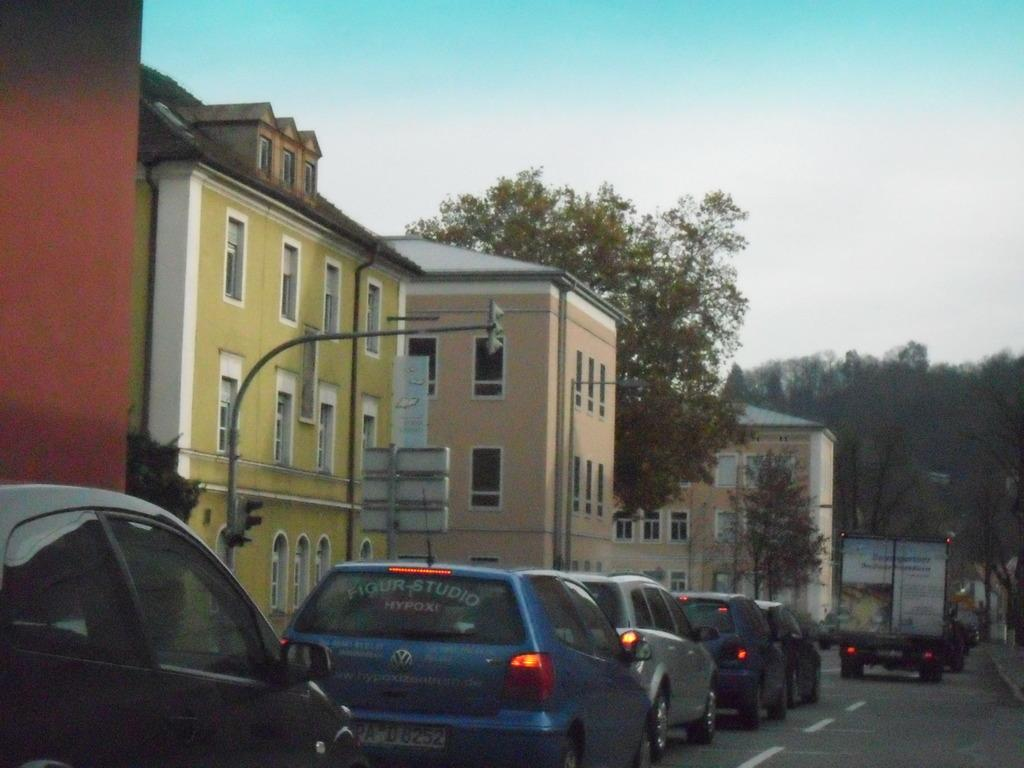What can be seen on the road in the image? There are vehicles on the road in the image. What type of structures are visible in the image? There are buildings visible in the image. What type of vegetation is present in the image? Trees are present in the image. What is visible in the background of the image? The sky is visible in the background of the image. What is the mass of the things floating in the sky in the image? There are no things floating in the sky in the image; only vehicles, buildings, trees, and the sky are present. How does the light affect the appearance of the buildings in the image? The provided facts do not mention any specific lighting conditions, so we cannot determine how the light affects the appearance of the buildings in the image. 